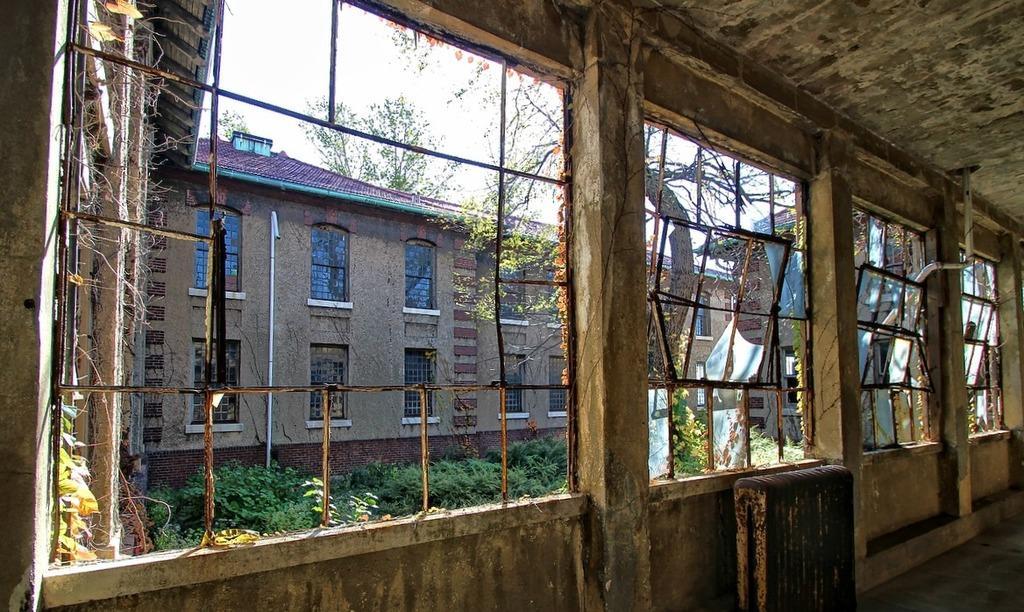Describe this image in one or two sentences. In this picture we can see few buildings, trees, plants and metal rods, and also we can see a pipe on the wall. 